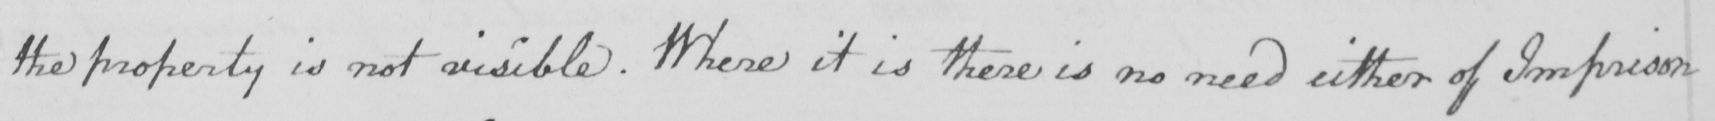What does this handwritten line say? the property is not visible . Where it is there is no need either of Imprison 